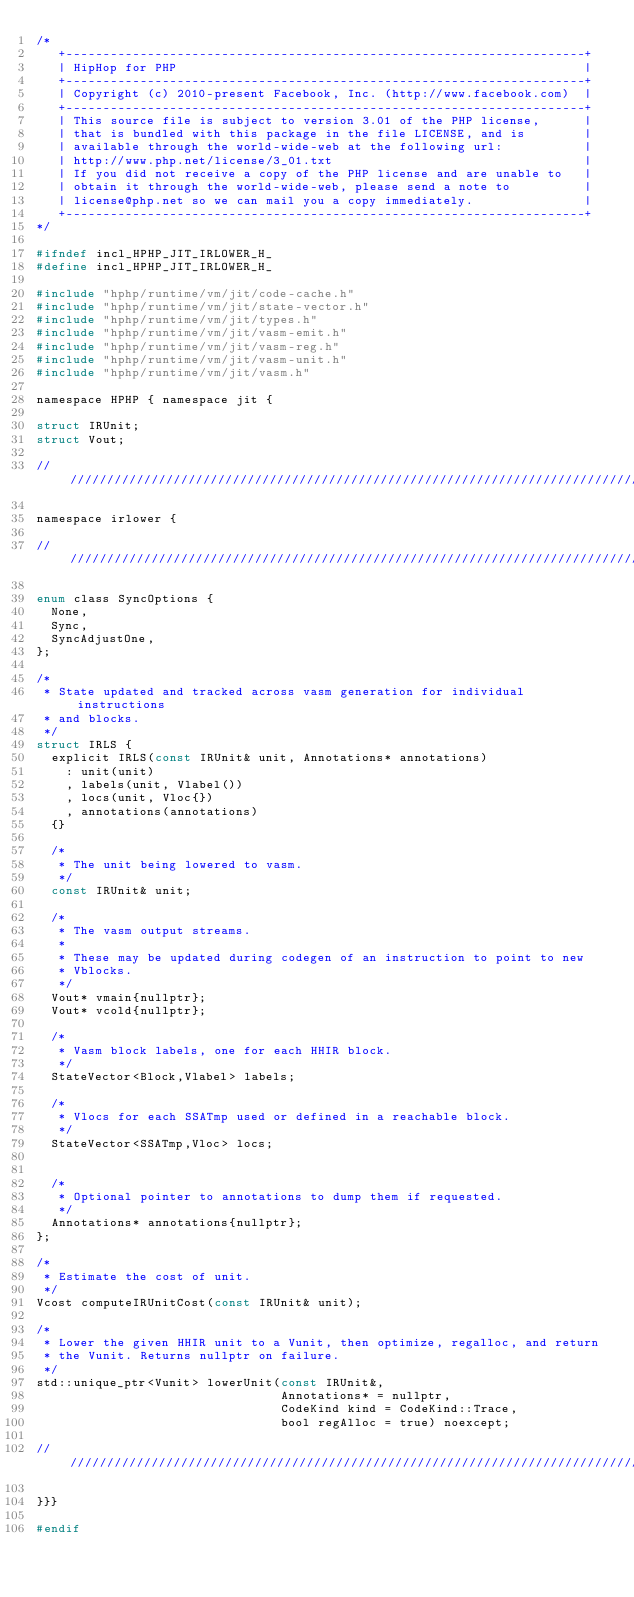<code> <loc_0><loc_0><loc_500><loc_500><_C_>/*
   +----------------------------------------------------------------------+
   | HipHop for PHP                                                       |
   +----------------------------------------------------------------------+
   | Copyright (c) 2010-present Facebook, Inc. (http://www.facebook.com)  |
   +----------------------------------------------------------------------+
   | This source file is subject to version 3.01 of the PHP license,      |
   | that is bundled with this package in the file LICENSE, and is        |
   | available through the world-wide-web at the following url:           |
   | http://www.php.net/license/3_01.txt                                  |
   | If you did not receive a copy of the PHP license and are unable to   |
   | obtain it through the world-wide-web, please send a note to          |
   | license@php.net so we can mail you a copy immediately.               |
   +----------------------------------------------------------------------+
*/

#ifndef incl_HPHP_JIT_IRLOWER_H_
#define incl_HPHP_JIT_IRLOWER_H_

#include "hphp/runtime/vm/jit/code-cache.h"
#include "hphp/runtime/vm/jit/state-vector.h"
#include "hphp/runtime/vm/jit/types.h"
#include "hphp/runtime/vm/jit/vasm-emit.h"
#include "hphp/runtime/vm/jit/vasm-reg.h"
#include "hphp/runtime/vm/jit/vasm-unit.h"
#include "hphp/runtime/vm/jit/vasm.h"

namespace HPHP { namespace jit {

struct IRUnit;
struct Vout;

///////////////////////////////////////////////////////////////////////////////

namespace irlower {

///////////////////////////////////////////////////////////////////////////////

enum class SyncOptions {
  None,
  Sync,
  SyncAdjustOne,
};

/*
 * State updated and tracked across vasm generation for individual instructions
 * and blocks.
 */
struct IRLS {
  explicit IRLS(const IRUnit& unit, Annotations* annotations)
    : unit(unit)
    , labels(unit, Vlabel())
    , locs(unit, Vloc{})
    , annotations(annotations)
  {}

  /*
   * The unit being lowered to vasm.
   */
  const IRUnit& unit;

  /*
   * The vasm output streams.
   *
   * These may be updated during codegen of an instruction to point to new
   * Vblocks.
   */
  Vout* vmain{nullptr};
  Vout* vcold{nullptr};

  /*
   * Vasm block labels, one for each HHIR block.
   */
  StateVector<Block,Vlabel> labels;

  /*
   * Vlocs for each SSATmp used or defined in a reachable block.
   */
  StateVector<SSATmp,Vloc> locs;


  /*
   * Optional pointer to annotations to dump them if requested.
   */
  Annotations* annotations{nullptr};
};

/*
 * Estimate the cost of unit.
 */
Vcost computeIRUnitCost(const IRUnit& unit);

/*
 * Lower the given HHIR unit to a Vunit, then optimize, regalloc, and return
 * the Vunit. Returns nullptr on failure.
 */
std::unique_ptr<Vunit> lowerUnit(const IRUnit&,
                                 Annotations* = nullptr,
                                 CodeKind kind = CodeKind::Trace,
                                 bool regAlloc = true) noexcept;

///////////////////////////////////////////////////////////////////////////////

}}}

#endif
</code> 